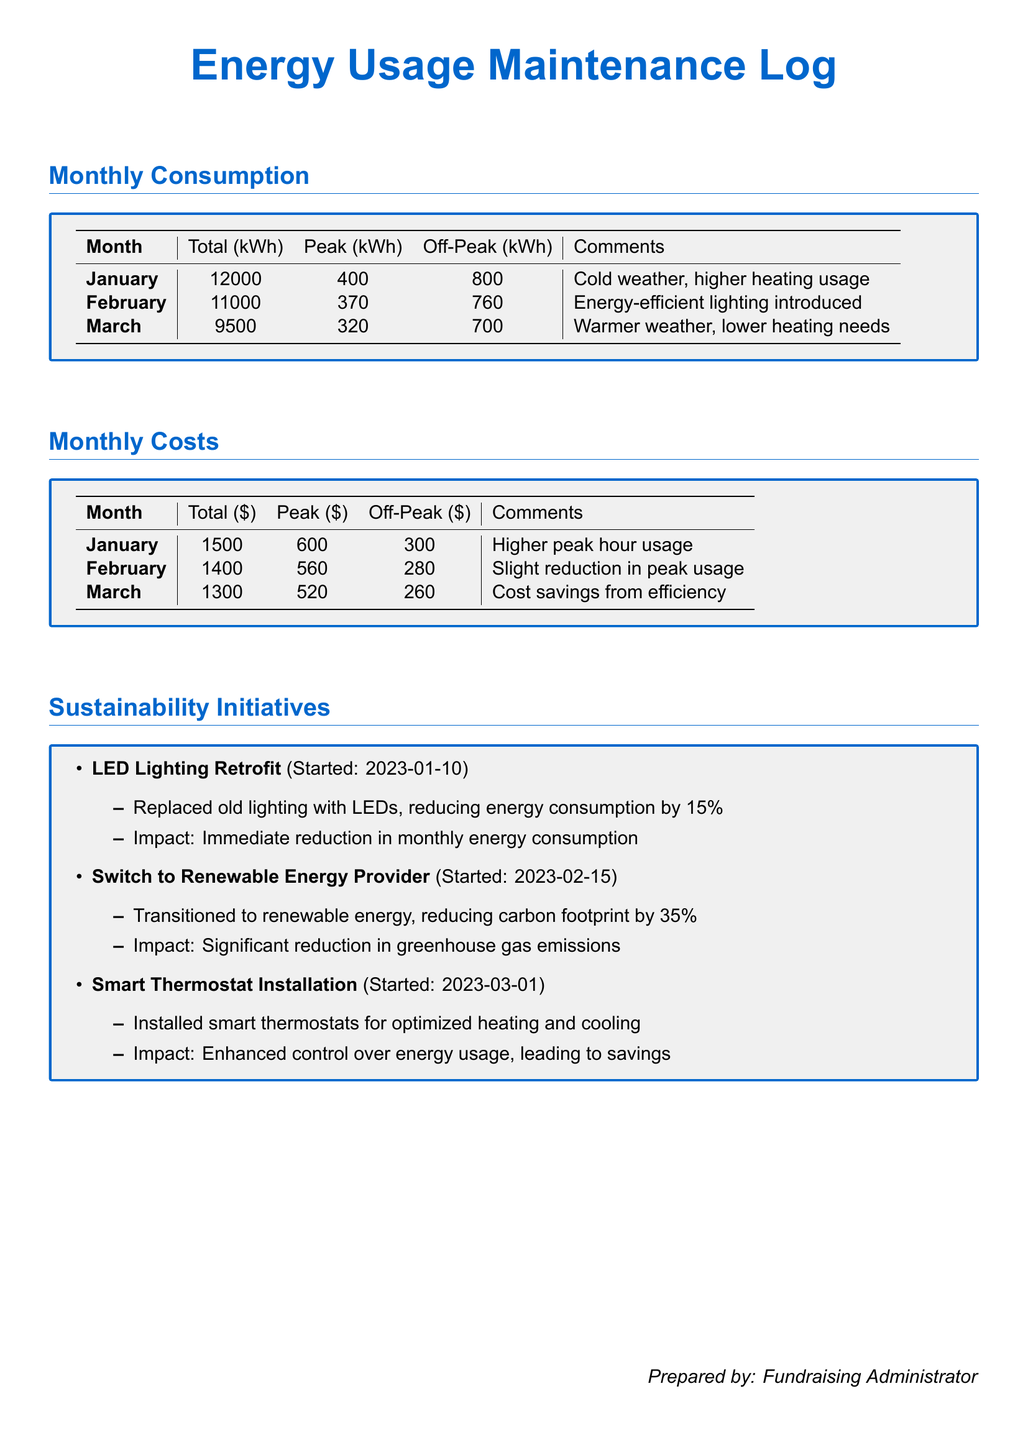What is the total energy consumption in January? The total energy consumption for January is noted in the Monthly Consumption section as 12000 kWh.
Answer: 12000 kWh What was the peak energy usage in February? The peak energy usage for February is specified in the Monthly Consumption section as 370 kWh.
Answer: 370 kWh What is the cost of energy in March? The total cost of energy for March is indicated in the Monthly Costs section as $1300.
Answer: $1300 What sustainability initiative started on January 10, 2023? The initiative that started on January 10, 2023, is the LED Lighting Retrofit mentioned in the Sustainability Initiatives section.
Answer: LED Lighting Retrofit What percent reduction in energy consumption was achieved through the LED retrofit? The document states that the LED retrofit led to a reduction in energy consumption by 15%.
Answer: 15% Which month had the highest total energy costs? The highest total energy cost is found in January, as shown in the Monthly Costs section.
Answer: January How much was saved in peak hour costs from February to March? The peak hour costs dropped from $560 in February to $520 in March, indicating a saving of $40.
Answer: $40 What is the reported reduction in carbon footprint from switching to a renewable energy provider? The reduction in carbon footprint from this initiative is cited as 35% in the Sustainability Initiatives section.
Answer: 35% What type of thermostats were installed starting in March? The type of thermostats installed is specified as smart thermostats in the Sustainability Initiatives section.
Answer: Smart thermostats 